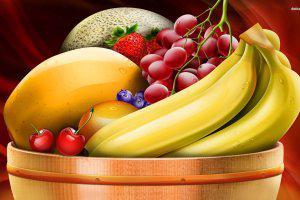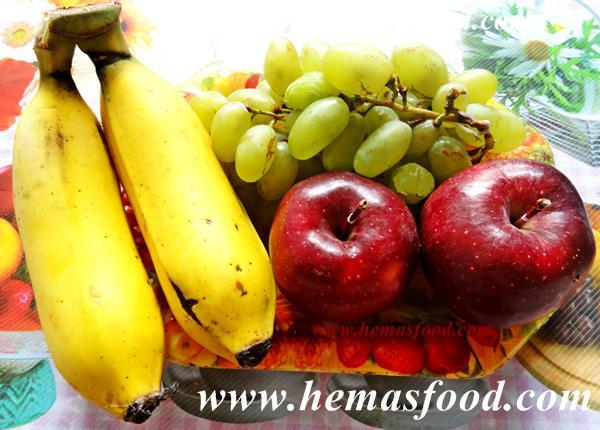The first image is the image on the left, the second image is the image on the right. Evaluate the accuracy of this statement regarding the images: "One of the images has at least one apple.". Is it true? Answer yes or no. Yes. The first image is the image on the left, the second image is the image on the right. Considering the images on both sides, is "There are red grapes and green grapes beside each-other in one of the images." valid? Answer yes or no. No. 